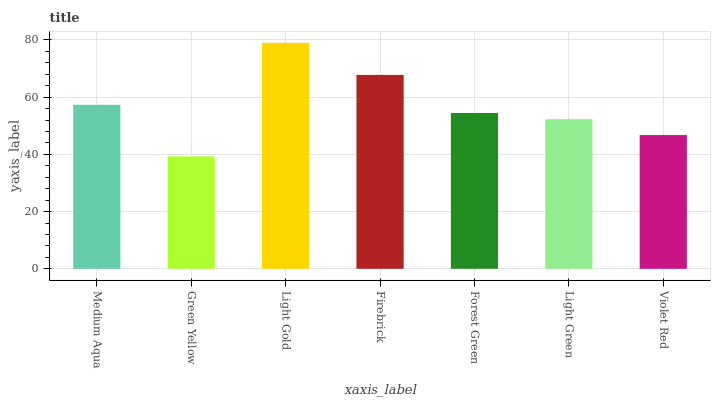Is Green Yellow the minimum?
Answer yes or no. Yes. Is Light Gold the maximum?
Answer yes or no. Yes. Is Light Gold the minimum?
Answer yes or no. No. Is Green Yellow the maximum?
Answer yes or no. No. Is Light Gold greater than Green Yellow?
Answer yes or no. Yes. Is Green Yellow less than Light Gold?
Answer yes or no. Yes. Is Green Yellow greater than Light Gold?
Answer yes or no. No. Is Light Gold less than Green Yellow?
Answer yes or no. No. Is Forest Green the high median?
Answer yes or no. Yes. Is Forest Green the low median?
Answer yes or no. Yes. Is Light Green the high median?
Answer yes or no. No. Is Green Yellow the low median?
Answer yes or no. No. 